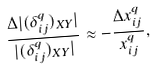<formula> <loc_0><loc_0><loc_500><loc_500>\frac { \Delta | ( \delta _ { i j } ^ { q } ) _ { X Y } | } { | ( \delta _ { i j } ^ { q } ) _ { X Y } | } \approx - \frac { \Delta x ^ { q } _ { i j } } { x _ { i j } ^ { q } } ,</formula> 